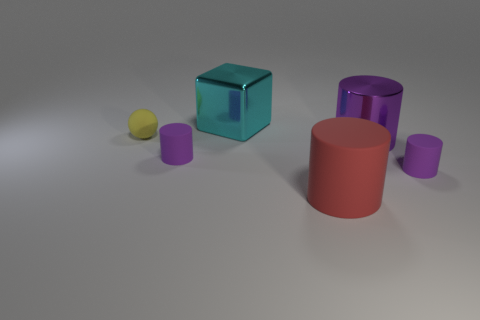How big is the purple thing behind the small purple rubber thing left of the shiny object in front of the yellow matte ball?
Your response must be concise. Large. What size is the metallic cube?
Make the answer very short. Large. Are there any other things that have the same material as the big cyan object?
Offer a terse response. Yes. There is a small thing right of the object behind the small matte ball; are there any purple objects that are in front of it?
Your answer should be compact. No. What number of tiny objects are either green rubber objects or yellow matte things?
Keep it short and to the point. 1. Are there any other things that have the same color as the shiny block?
Provide a succinct answer. No. There is a rubber cylinder that is on the left side of the red rubber object; is it the same size as the large matte cylinder?
Ensure brevity in your answer.  No. There is a object that is left of the tiny rubber cylinder to the left of the large object in front of the big purple metal cylinder; what color is it?
Provide a short and direct response. Yellow. The shiny cylinder is what color?
Provide a short and direct response. Purple. Is the large metallic cylinder the same color as the metallic cube?
Keep it short and to the point. No. 